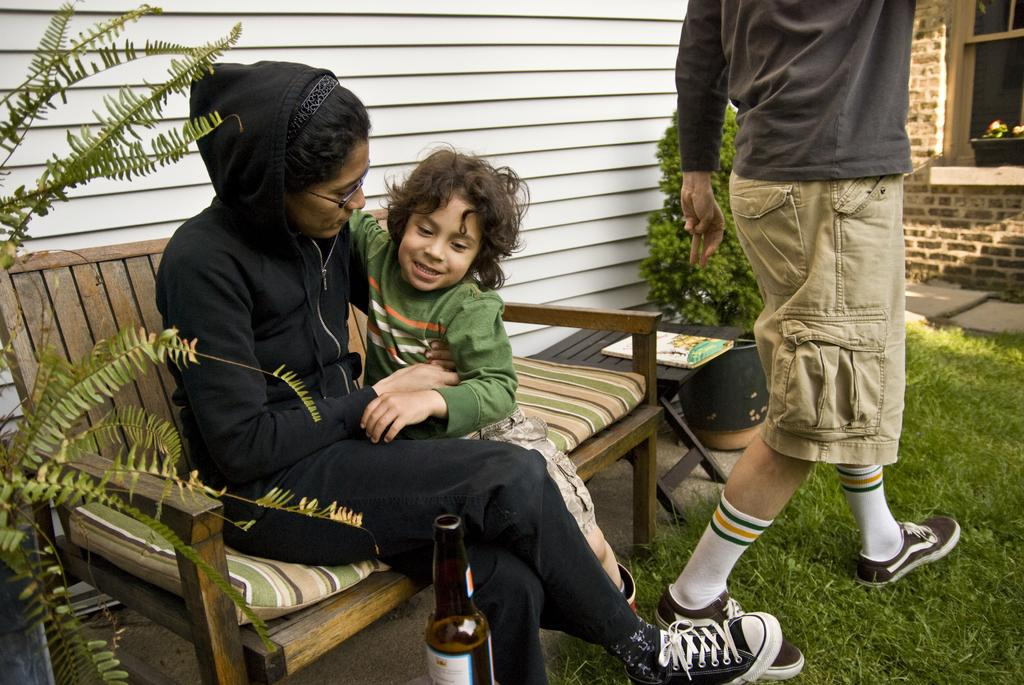Who are the people in the image? There is a woman and a boy in the image. What are they doing in the image? Both the woman and the boy are sitting on a bench. What can be seen in the background of the image? There is another person, a plant, a book, a table, grass, and a building in the background of the image. What type of card is being distributed by the stick in the image? There is no card or stick present in the image. 